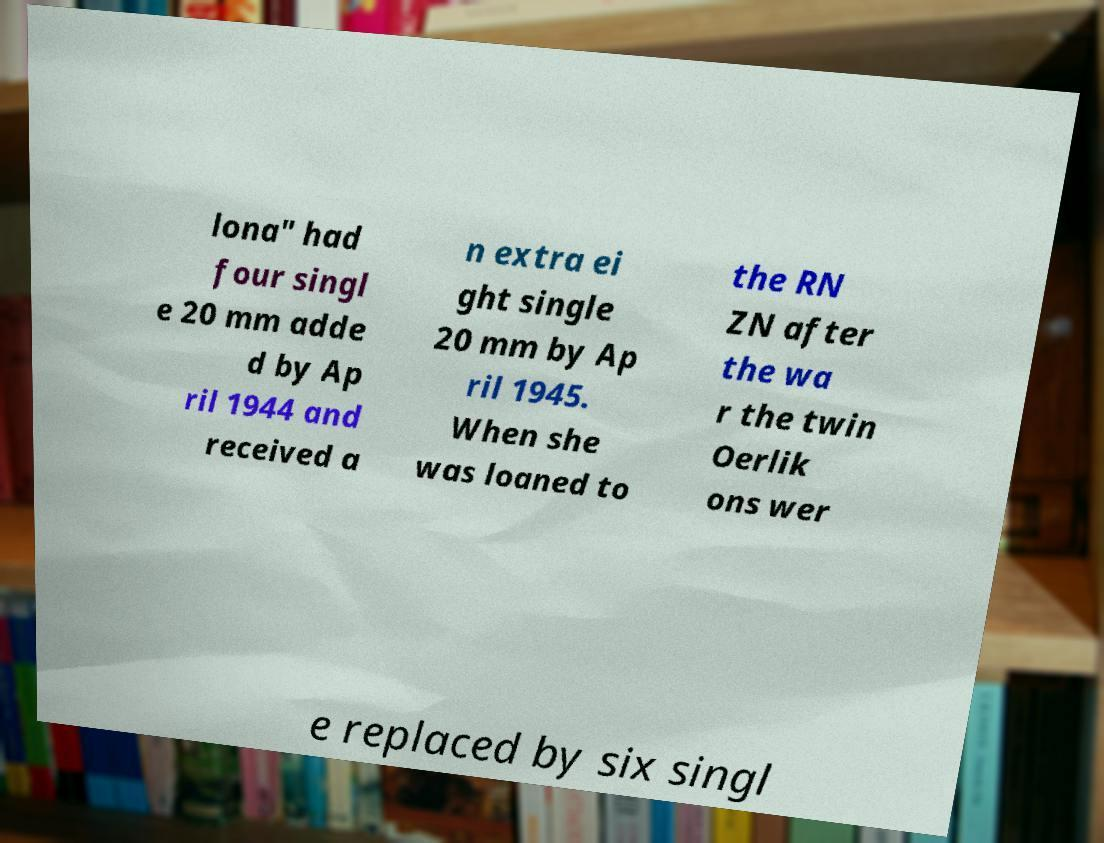There's text embedded in this image that I need extracted. Can you transcribe it verbatim? lona" had four singl e 20 mm adde d by Ap ril 1944 and received a n extra ei ght single 20 mm by Ap ril 1945. When she was loaned to the RN ZN after the wa r the twin Oerlik ons wer e replaced by six singl 